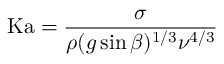Convert formula to latex. <formula><loc_0><loc_0><loc_500><loc_500>K a = { \frac { \sigma } { \rho ( g \sin \beta ) ^ { 1 / 3 } \nu ^ { 4 / 3 } } }</formula> 